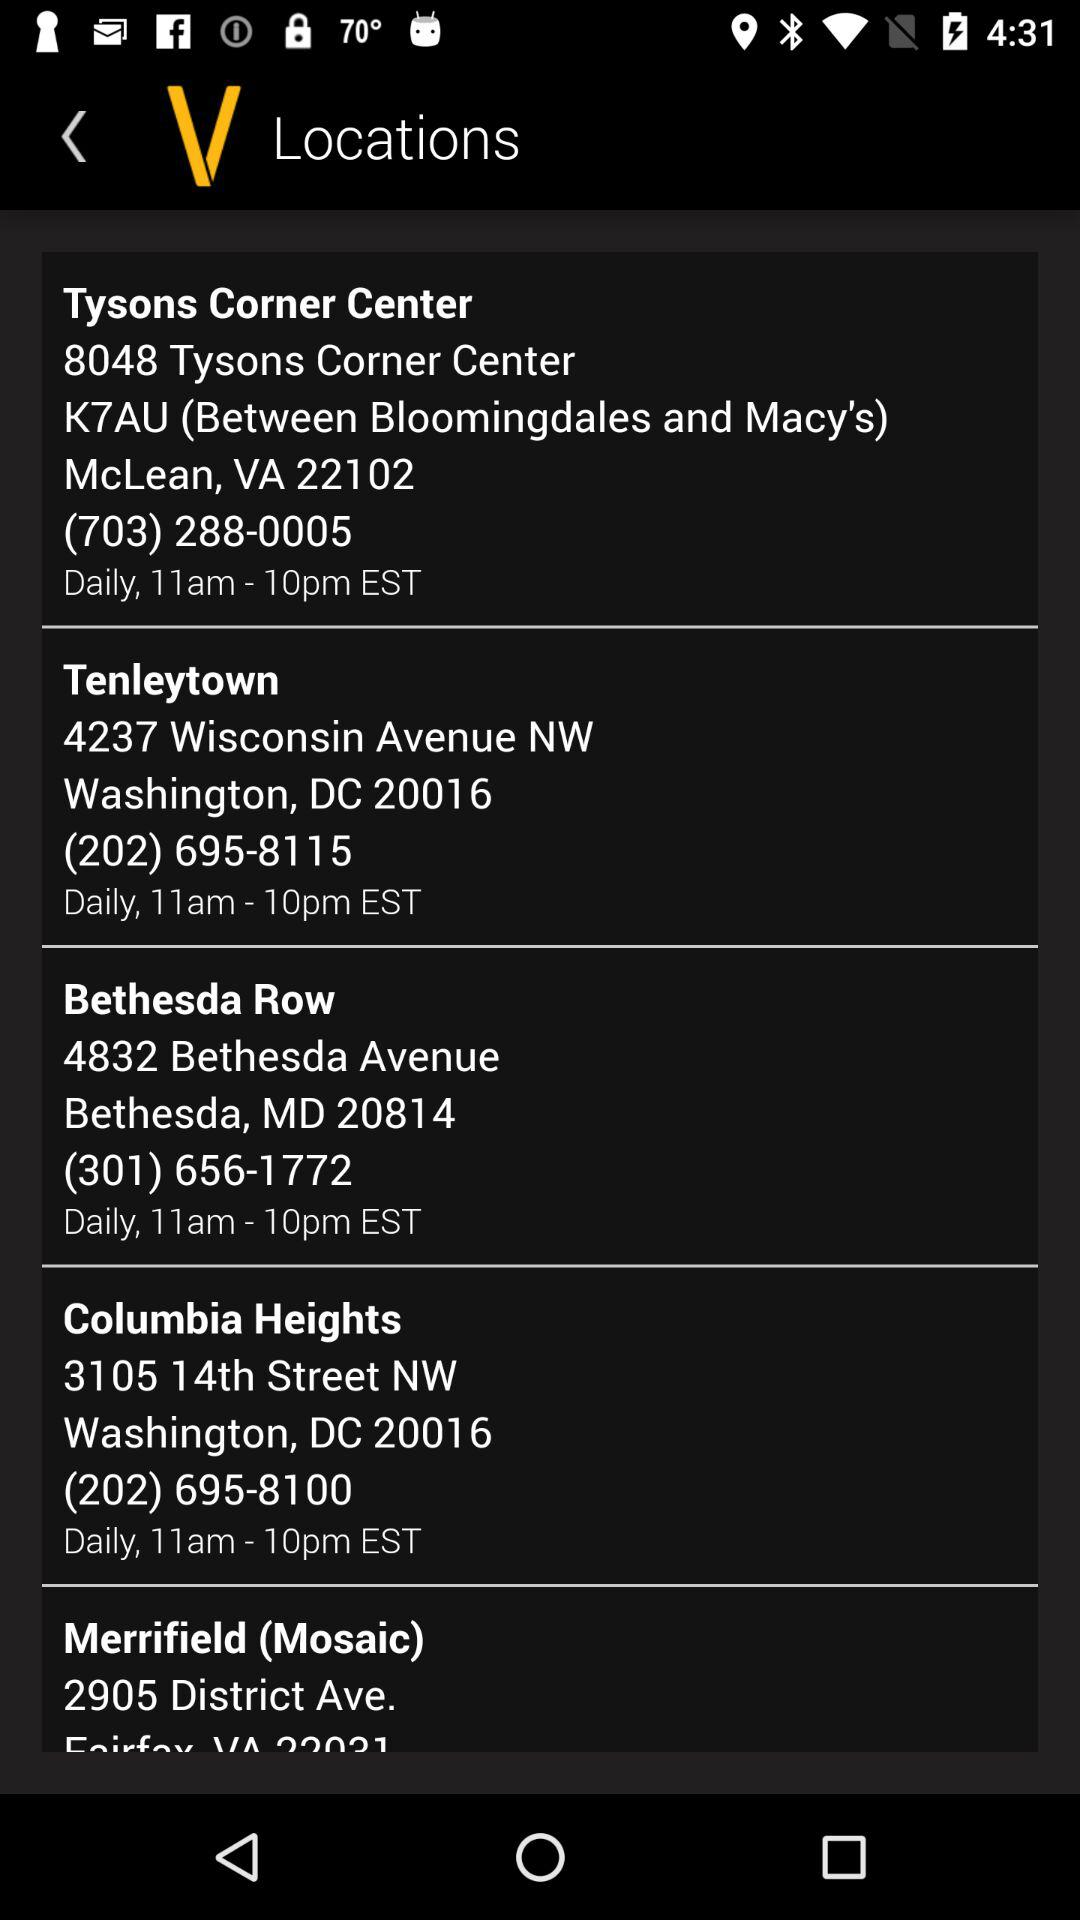What is the Zip code of Washington, DC? The Zip code is 20016. 